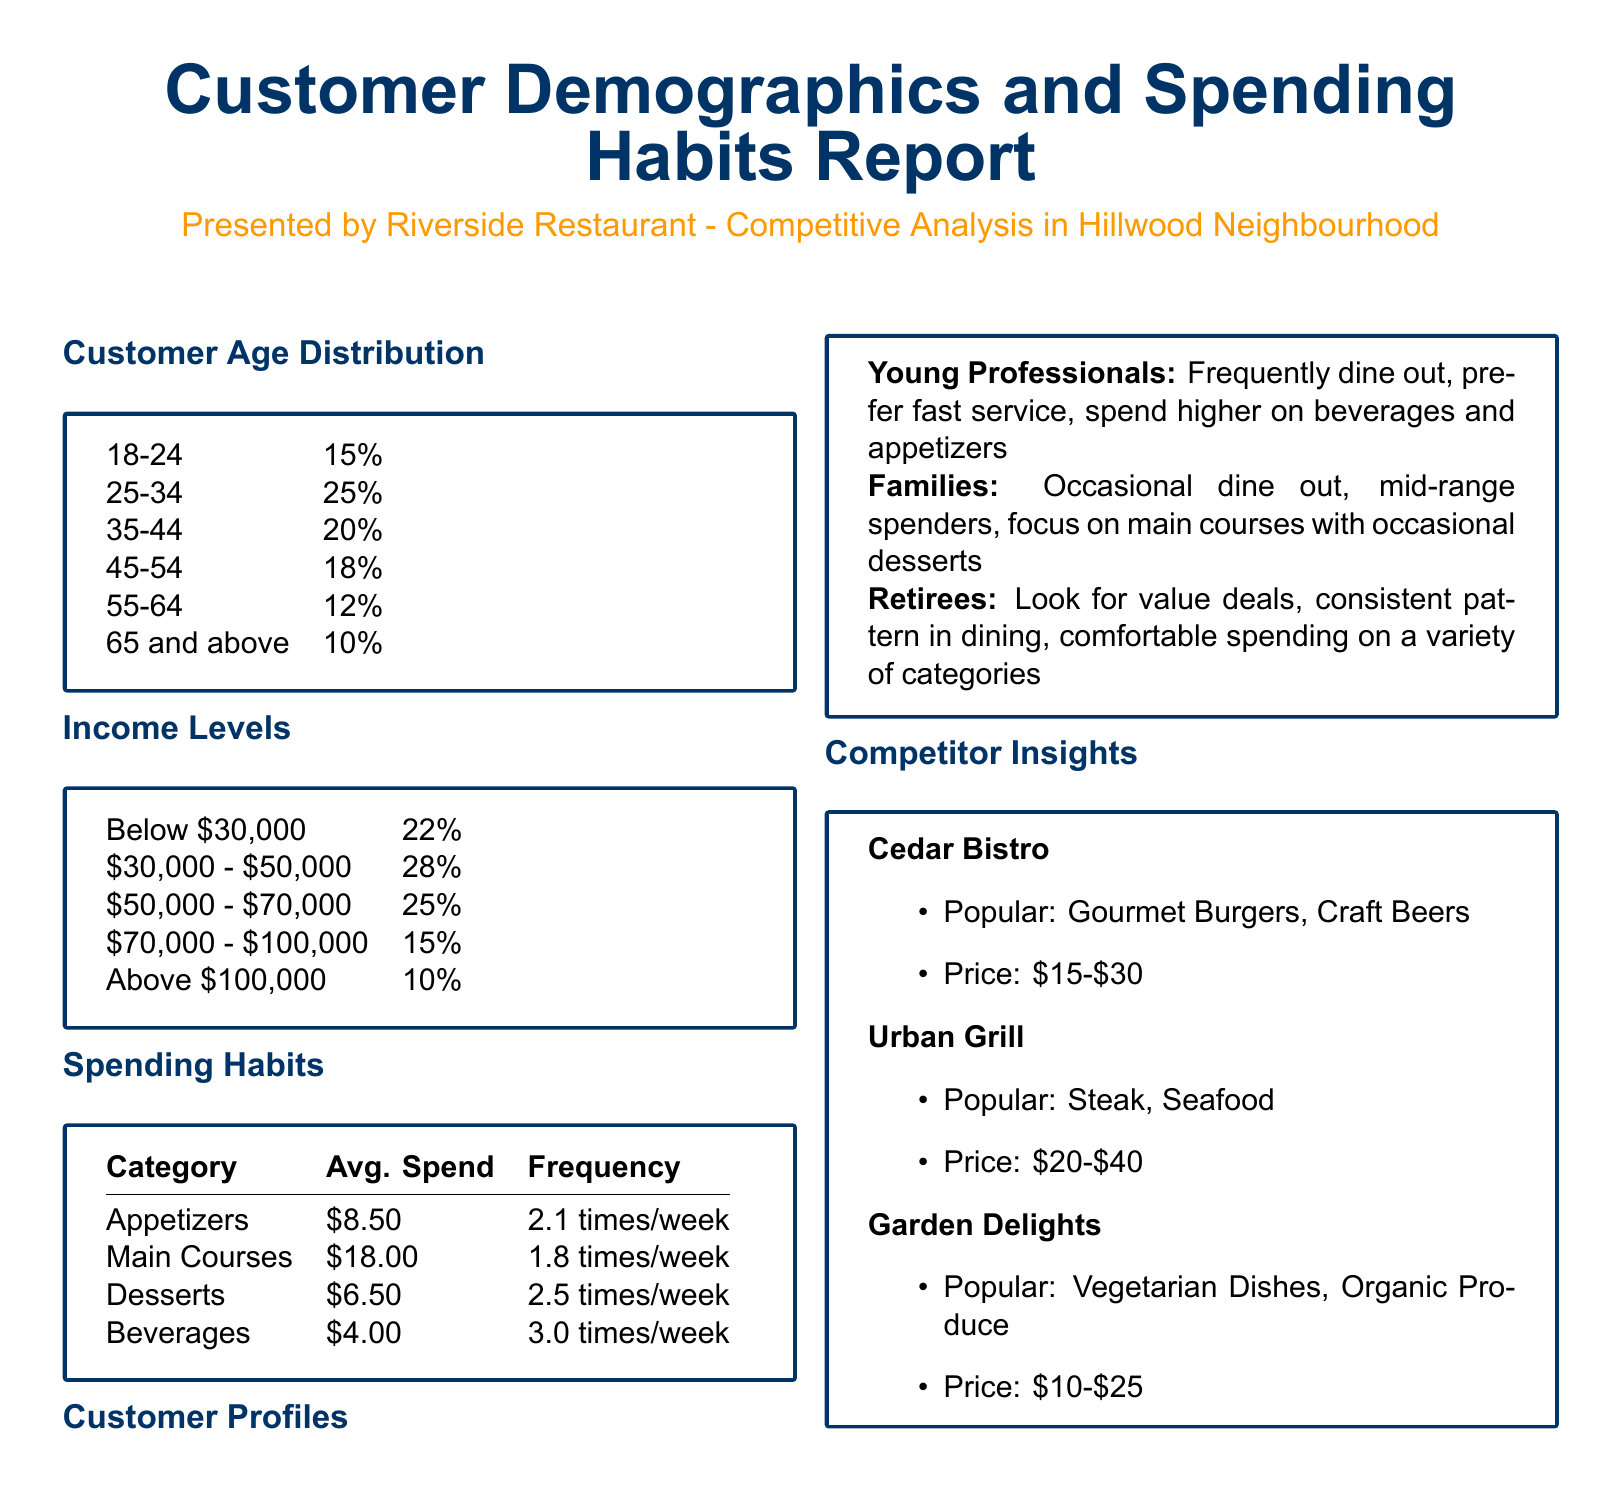What is the age group with the highest percentage? The age group with the highest percentage is 25-34, which has 25%.
Answer: 25-34 What percentage of customers are aged 65 and above? The document states that 10% of customers are aged 65 and above.
Answer: 10% What is the average spend on appetizers? The average spend on appetizers is listed as $8.50.
Answer: $8.50 How often do customers spend on beverages per week? Customers spend on beverages an average of 3.0 times a week.
Answer: 3.0 times/week Which customer profile is described as looking for value deals? The customer profile described as looking for value deals is Retirees.
Answer: Retirees Which competitor is known for vegetarian dishes? The competitor known for vegetarian dishes is Garden Delights.
Answer: Garden Delights What is the income level percentage for those earning below $30,000? 22% of customers have an income level below $30,000.
Answer: 22% Which category has the highest average spend frequency? The category with the highest average spend frequency is Desserts with 2.5 times/week.
Answer: Desserts What is the average spend for main courses? The average spend for main courses is $18.00.
Answer: $18.00 